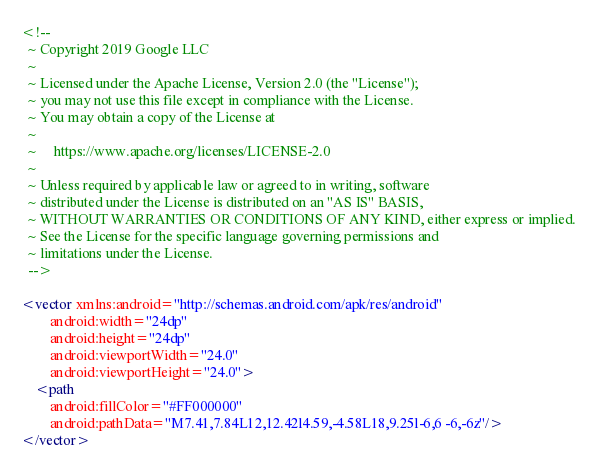<code> <loc_0><loc_0><loc_500><loc_500><_XML_><!--
  ~ Copyright 2019 Google LLC
  ~
  ~ Licensed under the Apache License, Version 2.0 (the "License");
  ~ you may not use this file except in compliance with the License.
  ~ You may obtain a copy of the License at
  ~
  ~     https://www.apache.org/licenses/LICENSE-2.0
  ~
  ~ Unless required by applicable law or agreed to in writing, software
  ~ distributed under the License is distributed on an "AS IS" BASIS,
  ~ WITHOUT WARRANTIES OR CONDITIONS OF ANY KIND, either express or implied.
  ~ See the License for the specific language governing permissions and
  ~ limitations under the License.
  -->

<vector xmlns:android="http://schemas.android.com/apk/res/android"
        android:width="24dp"
        android:height="24dp"
        android:viewportWidth="24.0"
        android:viewportHeight="24.0">
    <path
        android:fillColor="#FF000000"
        android:pathData="M7.41,7.84L12,12.42l4.59,-4.58L18,9.25l-6,6 -6,-6z"/>
</vector>
</code> 